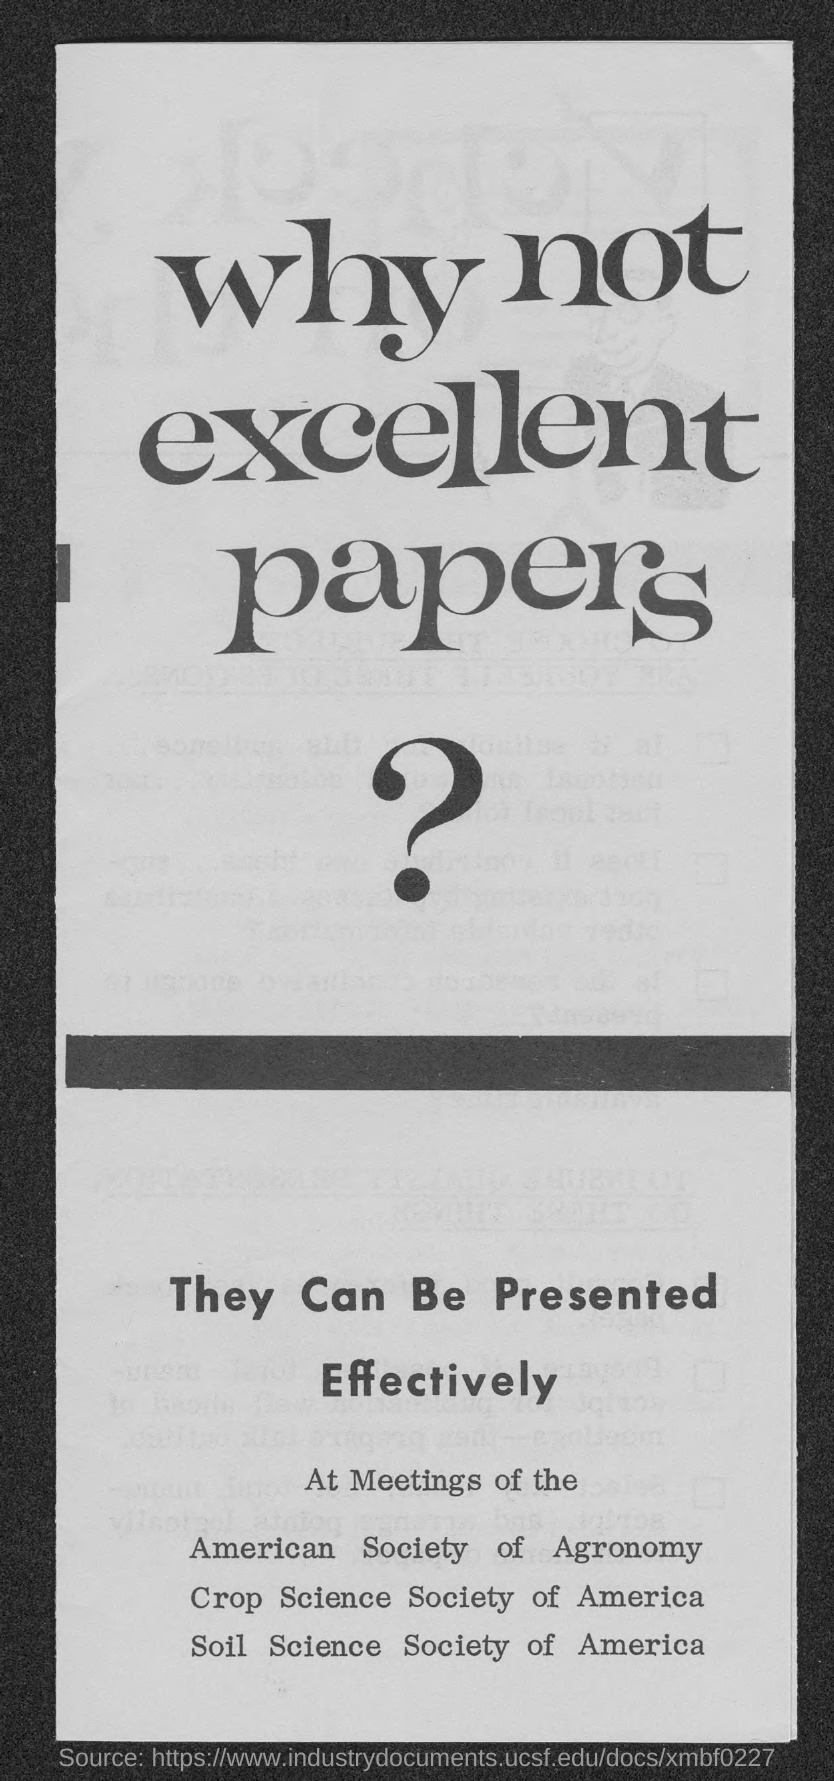What is the first title in the document?
Your response must be concise. Why not excellent papers?. What is the second title in the document?
Ensure brevity in your answer.  They can be Presented Effectively. 